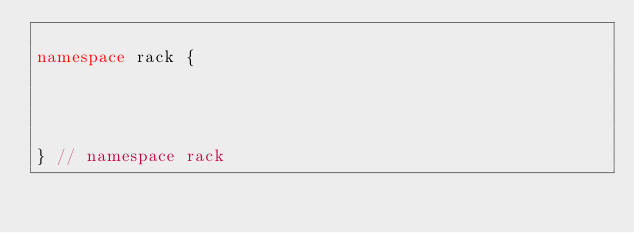<code> <loc_0><loc_0><loc_500><loc_500><_C++_>
namespace rack {




} // namespace rack
</code> 